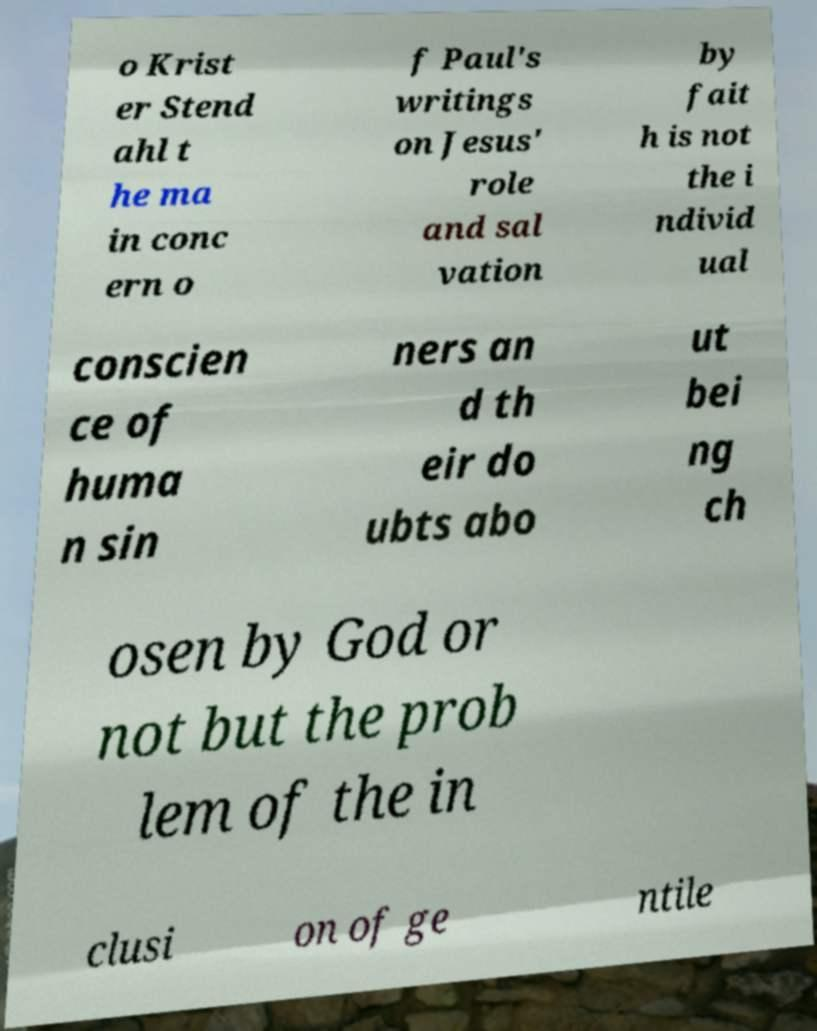Can you read and provide the text displayed in the image?This photo seems to have some interesting text. Can you extract and type it out for me? o Krist er Stend ahl t he ma in conc ern o f Paul's writings on Jesus' role and sal vation by fait h is not the i ndivid ual conscien ce of huma n sin ners an d th eir do ubts abo ut bei ng ch osen by God or not but the prob lem of the in clusi on of ge ntile 